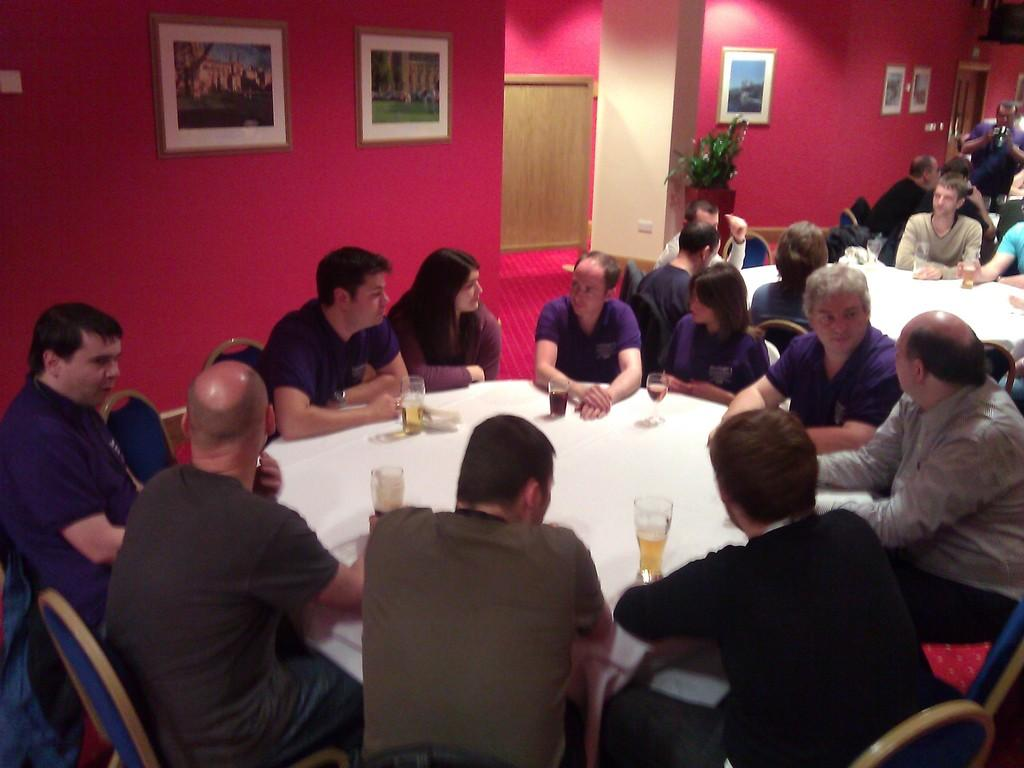What are the people in the image doing? The people in the image are sitting on chairs. How are the chairs arranged in the image? The chairs are arranged around a table. What can be seen on the table in the image? There are glasses on the table. What is hanging on the wall in the image? There are frames on the wall. What type of letters are being passed around the table in the image? There are no letters present in the image; it only shows people sitting on chairs around a table with glasses on it. 